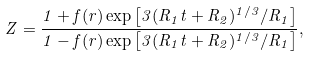Convert formula to latex. <formula><loc_0><loc_0><loc_500><loc_500>Z = \frac { 1 + f ( r ) \exp \left [ 3 ( R _ { 1 } t + R _ { 2 } ) ^ { 1 / 3 } / R _ { 1 } \right ] } { 1 - f ( r ) \exp \left [ 3 ( R _ { 1 } t + R _ { 2 } ) ^ { 1 / 3 } / R _ { 1 } \right ] } ,</formula> 